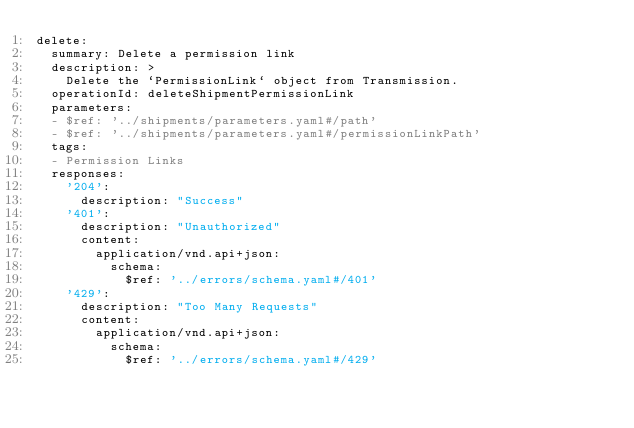<code> <loc_0><loc_0><loc_500><loc_500><_YAML_>delete:
  summary: Delete a permission link
  description: >
    Delete the `PermissionLink` object from Transmission.
  operationId: deleteShipmentPermissionLink
  parameters:
  - $ref: '../shipments/parameters.yaml#/path'
  - $ref: '../shipments/parameters.yaml#/permissionLinkPath'
  tags:
  - Permission Links
  responses:
    '204':
      description: "Success"
    '401':
      description: "Unauthorized"
      content:
        application/vnd.api+json:
          schema:
            $ref: '../errors/schema.yaml#/401'
    '429':
      description: "Too Many Requests"
      content:
        application/vnd.api+json:
          schema:
            $ref: '../errors/schema.yaml#/429'
</code> 